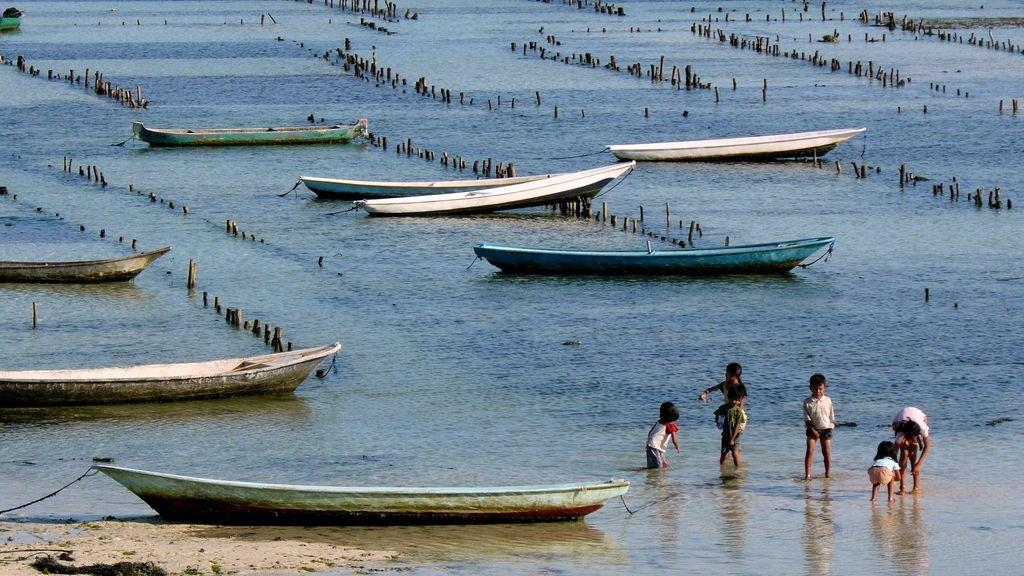What is the main subject in the front of the image? There is a boat in the front of the image on the water. What are the kids doing in the center of the image? The kids are standing in the water in the center of the image. What can be seen in the background of the image? There are boats visible in the background of the image on the water. What type of flag is flying over the downtown area in the image? There is no downtown area or flag present in the image; it features a boat in the front, kids standing in the water, and boats in the background. Is the ocean visible in the image? The image does not show the ocean; it features a body of water with boats and kids standing in it. 